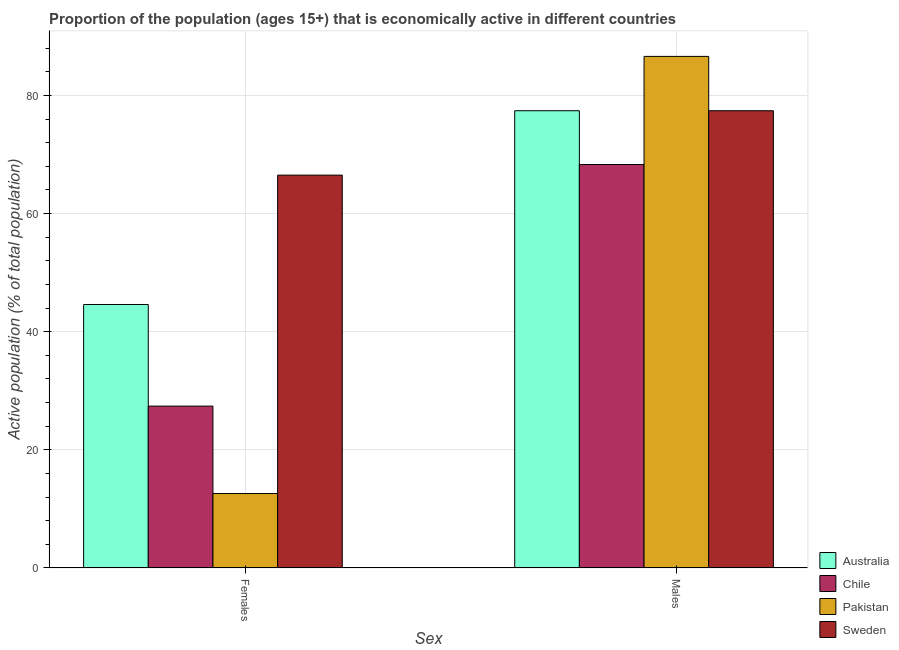How many different coloured bars are there?
Provide a short and direct response. 4. Are the number of bars on each tick of the X-axis equal?
Your answer should be compact. Yes. How many bars are there on the 2nd tick from the right?
Keep it short and to the point. 4. What is the label of the 1st group of bars from the left?
Your answer should be compact. Females. What is the percentage of economically active male population in Australia?
Provide a succinct answer. 77.4. Across all countries, what is the maximum percentage of economically active male population?
Offer a very short reply. 86.6. Across all countries, what is the minimum percentage of economically active male population?
Your answer should be compact. 68.3. In which country was the percentage of economically active male population maximum?
Give a very brief answer. Pakistan. In which country was the percentage of economically active female population minimum?
Ensure brevity in your answer.  Pakistan. What is the total percentage of economically active male population in the graph?
Give a very brief answer. 309.7. What is the difference between the percentage of economically active female population in Australia and that in Chile?
Offer a very short reply. 17.2. What is the difference between the percentage of economically active female population in Sweden and the percentage of economically active male population in Pakistan?
Ensure brevity in your answer.  -20.1. What is the average percentage of economically active female population per country?
Give a very brief answer. 37.77. What is the difference between the percentage of economically active male population and percentage of economically active female population in Pakistan?
Make the answer very short. 74. In how many countries, is the percentage of economically active female population greater than 8 %?
Keep it short and to the point. 4. What is the ratio of the percentage of economically active female population in Sweden to that in Pakistan?
Your answer should be compact. 5.28. In how many countries, is the percentage of economically active female population greater than the average percentage of economically active female population taken over all countries?
Offer a terse response. 2. How many countries are there in the graph?
Keep it short and to the point. 4. What is the difference between two consecutive major ticks on the Y-axis?
Make the answer very short. 20. Are the values on the major ticks of Y-axis written in scientific E-notation?
Make the answer very short. No. Does the graph contain any zero values?
Offer a very short reply. No. Where does the legend appear in the graph?
Keep it short and to the point. Bottom right. How many legend labels are there?
Provide a succinct answer. 4. How are the legend labels stacked?
Ensure brevity in your answer.  Vertical. What is the title of the graph?
Keep it short and to the point. Proportion of the population (ages 15+) that is economically active in different countries. Does "Guyana" appear as one of the legend labels in the graph?
Give a very brief answer. No. What is the label or title of the X-axis?
Provide a short and direct response. Sex. What is the label or title of the Y-axis?
Give a very brief answer. Active population (% of total population). What is the Active population (% of total population) of Australia in Females?
Keep it short and to the point. 44.6. What is the Active population (% of total population) of Chile in Females?
Your answer should be compact. 27.4. What is the Active population (% of total population) in Pakistan in Females?
Give a very brief answer. 12.6. What is the Active population (% of total population) of Sweden in Females?
Your answer should be compact. 66.5. What is the Active population (% of total population) in Australia in Males?
Your answer should be compact. 77.4. What is the Active population (% of total population) in Chile in Males?
Make the answer very short. 68.3. What is the Active population (% of total population) in Pakistan in Males?
Your answer should be compact. 86.6. What is the Active population (% of total population) of Sweden in Males?
Give a very brief answer. 77.4. Across all Sex, what is the maximum Active population (% of total population) in Australia?
Give a very brief answer. 77.4. Across all Sex, what is the maximum Active population (% of total population) in Chile?
Provide a succinct answer. 68.3. Across all Sex, what is the maximum Active population (% of total population) of Pakistan?
Your answer should be compact. 86.6. Across all Sex, what is the maximum Active population (% of total population) in Sweden?
Your response must be concise. 77.4. Across all Sex, what is the minimum Active population (% of total population) in Australia?
Offer a terse response. 44.6. Across all Sex, what is the minimum Active population (% of total population) in Chile?
Offer a terse response. 27.4. Across all Sex, what is the minimum Active population (% of total population) in Pakistan?
Make the answer very short. 12.6. Across all Sex, what is the minimum Active population (% of total population) of Sweden?
Ensure brevity in your answer.  66.5. What is the total Active population (% of total population) in Australia in the graph?
Your answer should be compact. 122. What is the total Active population (% of total population) of Chile in the graph?
Provide a short and direct response. 95.7. What is the total Active population (% of total population) in Pakistan in the graph?
Give a very brief answer. 99.2. What is the total Active population (% of total population) of Sweden in the graph?
Make the answer very short. 143.9. What is the difference between the Active population (% of total population) in Australia in Females and that in Males?
Your response must be concise. -32.8. What is the difference between the Active population (% of total population) in Chile in Females and that in Males?
Provide a short and direct response. -40.9. What is the difference between the Active population (% of total population) in Pakistan in Females and that in Males?
Offer a terse response. -74. What is the difference between the Active population (% of total population) in Australia in Females and the Active population (% of total population) in Chile in Males?
Your answer should be very brief. -23.7. What is the difference between the Active population (% of total population) in Australia in Females and the Active population (% of total population) in Pakistan in Males?
Make the answer very short. -42. What is the difference between the Active population (% of total population) in Australia in Females and the Active population (% of total population) in Sweden in Males?
Your answer should be compact. -32.8. What is the difference between the Active population (% of total population) in Chile in Females and the Active population (% of total population) in Pakistan in Males?
Make the answer very short. -59.2. What is the difference between the Active population (% of total population) in Chile in Females and the Active population (% of total population) in Sweden in Males?
Your answer should be compact. -50. What is the difference between the Active population (% of total population) in Pakistan in Females and the Active population (% of total population) in Sweden in Males?
Provide a short and direct response. -64.8. What is the average Active population (% of total population) in Chile per Sex?
Give a very brief answer. 47.85. What is the average Active population (% of total population) of Pakistan per Sex?
Make the answer very short. 49.6. What is the average Active population (% of total population) in Sweden per Sex?
Give a very brief answer. 71.95. What is the difference between the Active population (% of total population) in Australia and Active population (% of total population) in Pakistan in Females?
Ensure brevity in your answer.  32. What is the difference between the Active population (% of total population) of Australia and Active population (% of total population) of Sweden in Females?
Ensure brevity in your answer.  -21.9. What is the difference between the Active population (% of total population) of Chile and Active population (% of total population) of Sweden in Females?
Your answer should be very brief. -39.1. What is the difference between the Active population (% of total population) of Pakistan and Active population (% of total population) of Sweden in Females?
Offer a very short reply. -53.9. What is the difference between the Active population (% of total population) of Australia and Active population (% of total population) of Chile in Males?
Offer a terse response. 9.1. What is the difference between the Active population (% of total population) of Australia and Active population (% of total population) of Pakistan in Males?
Offer a terse response. -9.2. What is the difference between the Active population (% of total population) in Australia and Active population (% of total population) in Sweden in Males?
Your response must be concise. 0. What is the difference between the Active population (% of total population) in Chile and Active population (% of total population) in Pakistan in Males?
Keep it short and to the point. -18.3. What is the ratio of the Active population (% of total population) in Australia in Females to that in Males?
Ensure brevity in your answer.  0.58. What is the ratio of the Active population (% of total population) in Chile in Females to that in Males?
Provide a short and direct response. 0.4. What is the ratio of the Active population (% of total population) of Pakistan in Females to that in Males?
Give a very brief answer. 0.15. What is the ratio of the Active population (% of total population) of Sweden in Females to that in Males?
Give a very brief answer. 0.86. What is the difference between the highest and the second highest Active population (% of total population) of Australia?
Ensure brevity in your answer.  32.8. What is the difference between the highest and the second highest Active population (% of total population) in Chile?
Offer a terse response. 40.9. What is the difference between the highest and the second highest Active population (% of total population) of Pakistan?
Provide a succinct answer. 74. What is the difference between the highest and the second highest Active population (% of total population) of Sweden?
Provide a short and direct response. 10.9. What is the difference between the highest and the lowest Active population (% of total population) in Australia?
Keep it short and to the point. 32.8. What is the difference between the highest and the lowest Active population (% of total population) of Chile?
Your response must be concise. 40.9. What is the difference between the highest and the lowest Active population (% of total population) in Pakistan?
Keep it short and to the point. 74. 